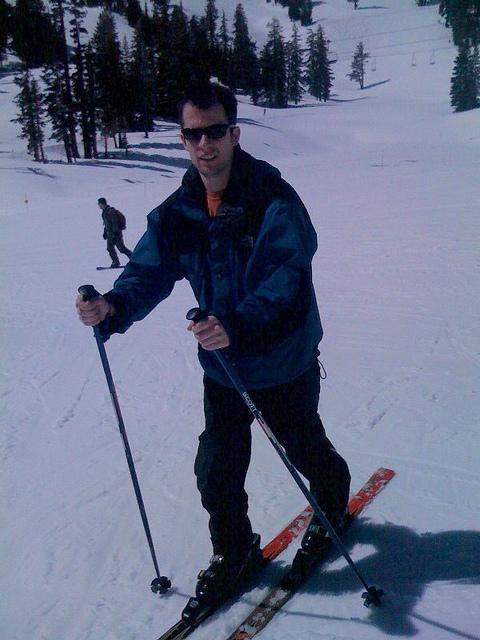Can you see this person's face?
Concise answer only. Yes. Are those adult skis?
Keep it brief. Yes. What is covering the man's eyes?
Give a very brief answer. Sunglasses. How many people are in this picture?
Concise answer only. 2. Is the weather very cold?
Keep it brief. Yes. Is the person wearing a hat?
Quick response, please. No. How is the man dressed?
Concise answer only. Warm. How many poles are touching the snow?
Answer briefly. 2. 